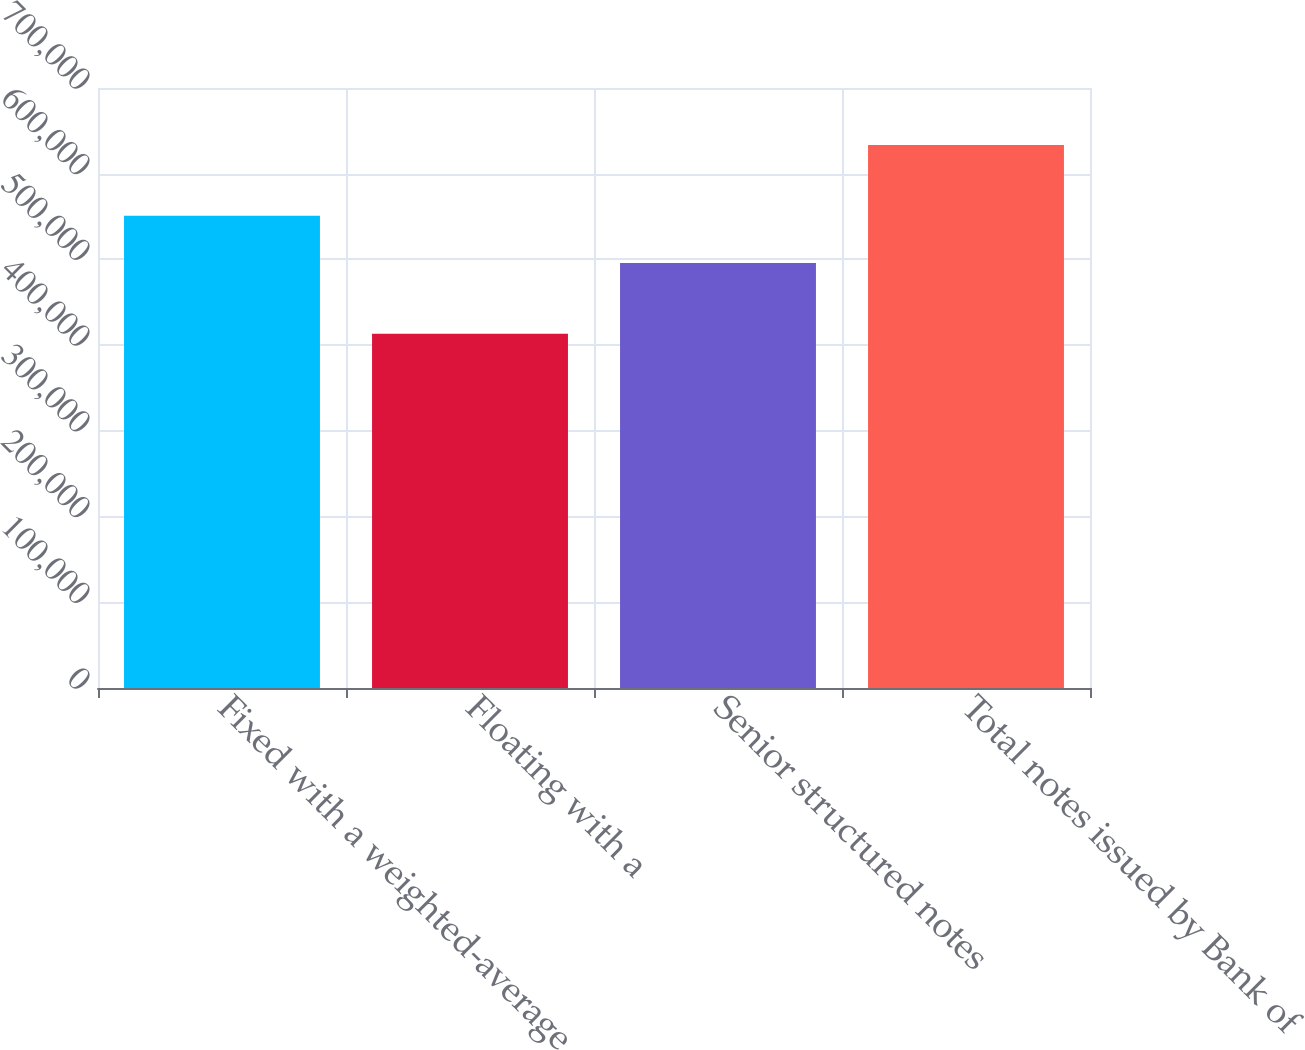Convert chart. <chart><loc_0><loc_0><loc_500><loc_500><bar_chart><fcel>Fixed with a weighted-average<fcel>Floating with a<fcel>Senior structured notes<fcel>Total notes issued by Bank of<nl><fcel>550992<fcel>413288<fcel>495911<fcel>633614<nl></chart> 